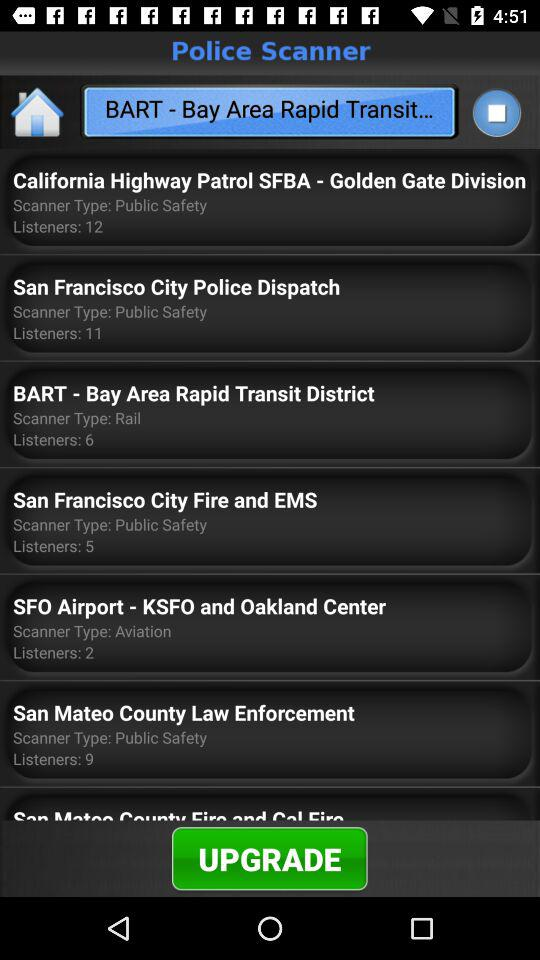What is the number of listeners for BART? The number of listeners for BART is 6. 